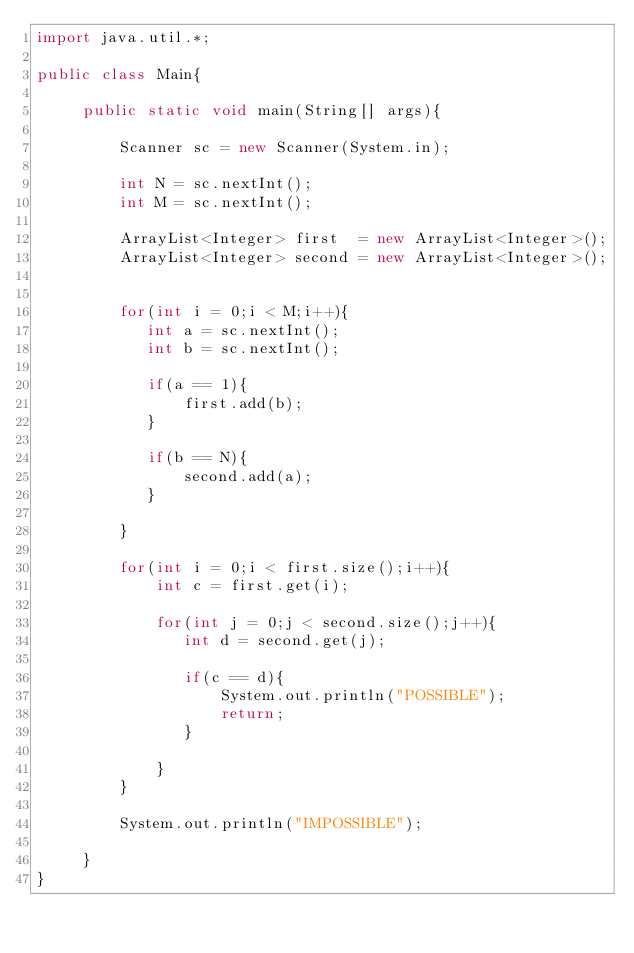Convert code to text. <code><loc_0><loc_0><loc_500><loc_500><_Java_>import java.util.*;

public class Main{            
    
     public static void main(String[] args){
      
         Scanner sc = new Scanner(System.in);
         
         int N = sc.nextInt();
         int M = sc.nextInt();        
         
         ArrayList<Integer> first  = new ArrayList<Integer>();
         ArrayList<Integer> second = new ArrayList<Integer>();
         
         
         for(int i = 0;i < M;i++){
            int a = sc.nextInt();
            int b = sc.nextInt();
            
            if(a == 1){
                first.add(b);
            }      
            
            if(b == N){
                second.add(a);
            }            
            
         }
         
         for(int i = 0;i < first.size();i++){
             int c = first.get(i);
             
             for(int j = 0;j < second.size();j++){
                int d = second.get(j);
                
                if(c == d){
                    System.out.println("POSSIBLE");
                    return;
                }
                
             }                          
         }
         
         System.out.println("IMPOSSIBLE");
         
     }              
}       

</code> 